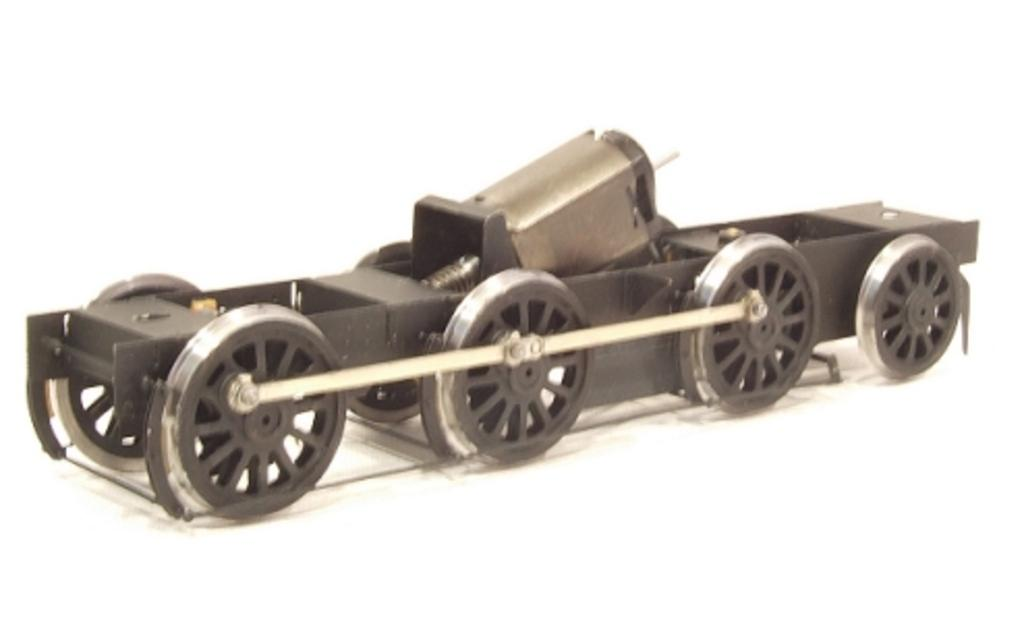What is the main subject of the image? The main subject of the image is a vehicle. How many wheels does the vehicle have? The vehicle has eight wheels. What type of credit is the vehicle using to pay for its fuel in the image? There is no indication in the image that the vehicle is using credit to pay for its fuel, as the image does not show any payment method or fuel station. 